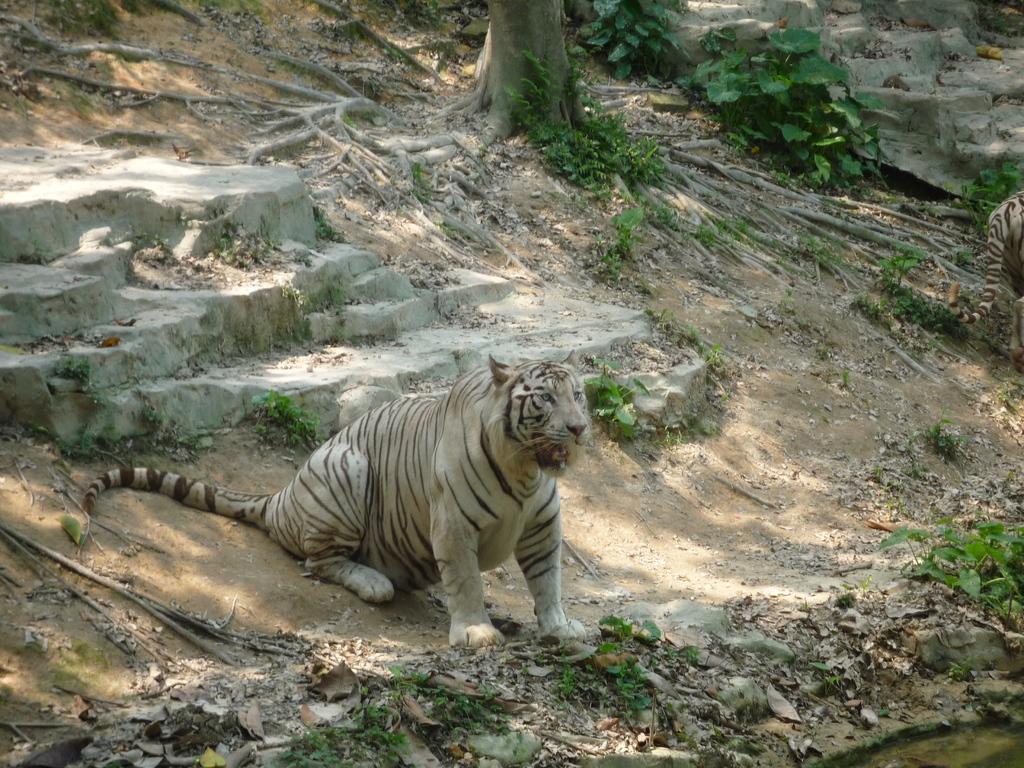Please provide a concise description of this image. There is a tiger, stairs, a tree trunk and plants. 